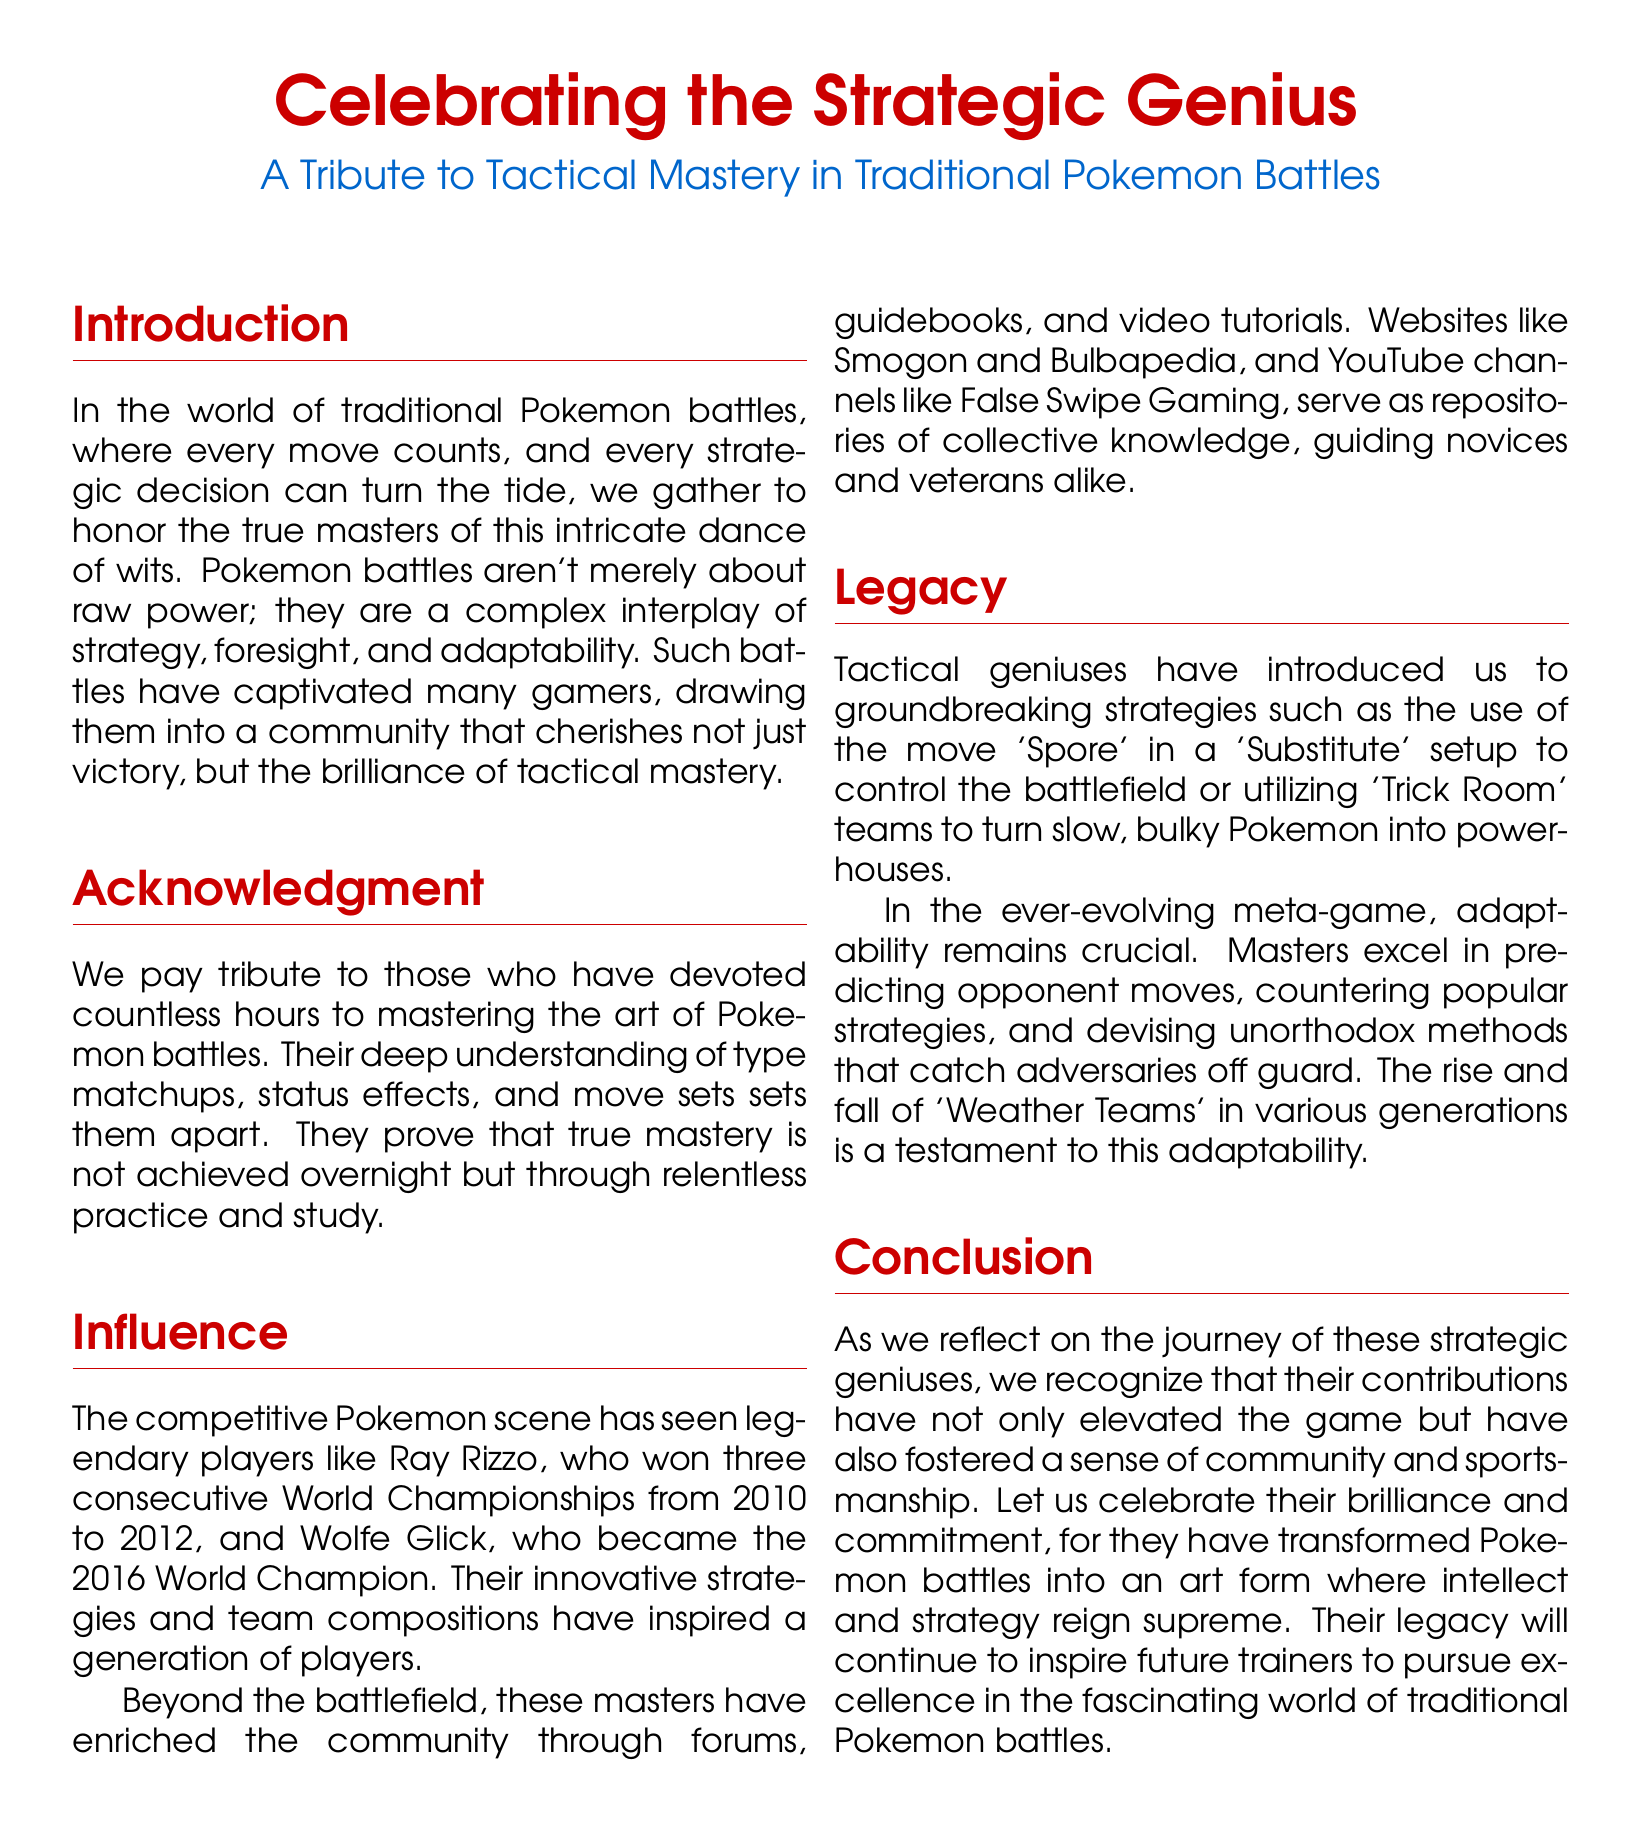What is the title of the document? The title of the document is presented prominently at the top, emphasizing the theme of strategic mastery in Pokémon battles.
Answer: Celebrating the Strategic Genius Who are the two legendary players mentioned in the document? The document highlights two legendary players who have made significant contributions to the competitive scene, specifically acknowledging their championships.
Answer: Ray Rizzo and Wolfe Glick In which years did Ray Rizzo win the World Championships? This information is contained within the influence section, detailing the achievements of prominent players.
Answer: 2010 to 2012 What move is discussed in a groundbreaking strategy introduced by tactical geniuses? The document describes specific moves that have changed the approach in battles, particularly noted in the legacy section.
Answer: Spore What do ‘Weather Teams’ represent in the context of the document? The document discusses ‘Weather Teams’ as part of the adaptability in the meta-game within Pokémon battles.
Answer: Adaptability What is the primary focus of the document? The document's main theme revolves around honoring those who excel in tactical gameplay in Pokémon battles.
Answer: Tactical Mastery What community contributions are mentioned in the document? The contributions of notable players extend beyond battles, enriching the community through various platforms.
Answer: Forums, guidebooks, and video tutorials What is the closing sentiment of the document? Reflecting on the contributions of masters, the conclusion emphasizes a commitment to excellence and community in the Pokémon battle scene.
Answer: Celebrate their brilliance and commitment 